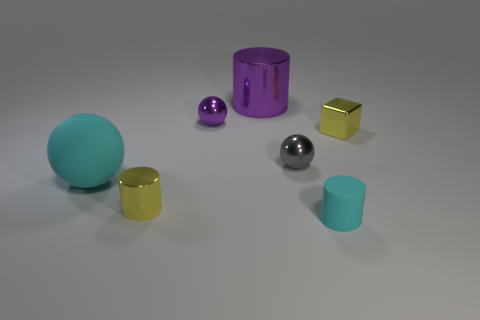Add 3 gray metallic cubes. How many objects exist? 10 Subtract all spheres. How many objects are left? 4 Subtract 0 purple blocks. How many objects are left? 7 Subtract all cyan rubber cylinders. Subtract all rubber objects. How many objects are left? 4 Add 4 large purple cylinders. How many large purple cylinders are left? 5 Add 1 small gray shiny objects. How many small gray shiny objects exist? 2 